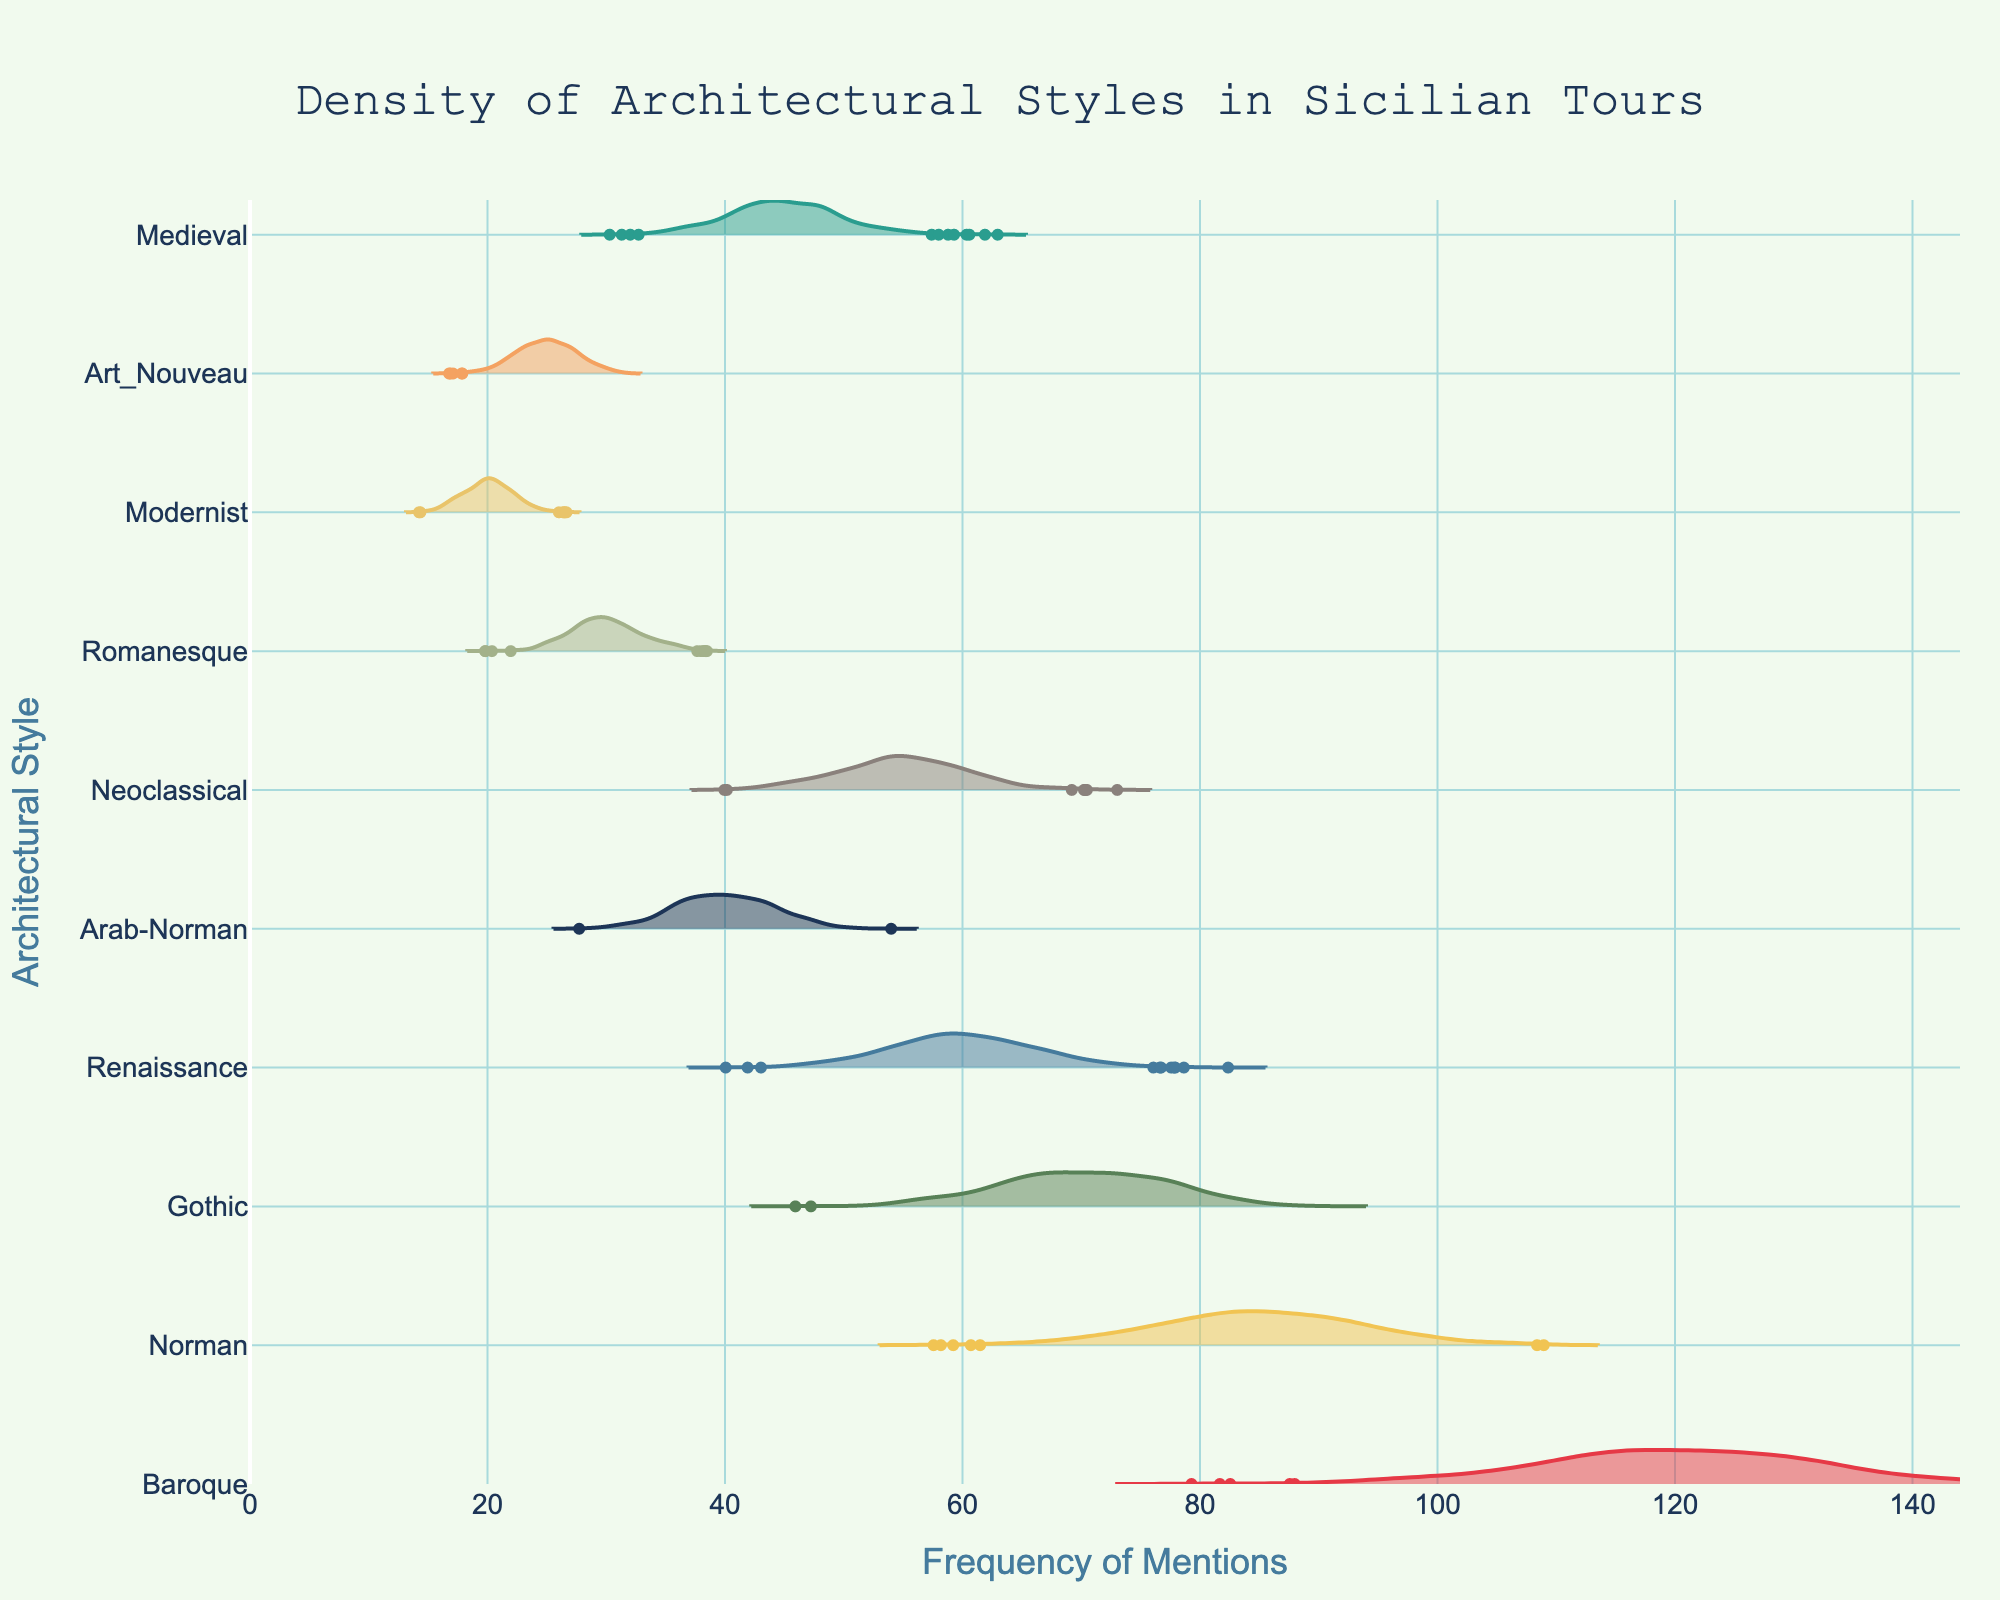What's the title of the plot? The title is displayed prominently at the top of the figure.
Answer: Density of Architectural Styles in Sicilian Tours What is the architectural style with the highest frequency of mentions? Look for the architectural style whose density plot is centered around the highest value on the x-axis.
Answer: Baroque Which style has the lowest frequency of mentions? Identify the architectural style whose density plot is centered around the lowest value on the x-axis.
Answer: Modernist How many architectural styles are displayed in the plot? Count the number of distinct density plots represented in the figure.
Answer: 10 Compare the frequency of mentions for Norman and Art Nouveau styles. Which one is mentioned more frequently? Locate the density plots for Norman and Art Nouveau and compare their center points along the x-axis.
Answer: Norman Which architectural style has a frequency of mentions closer to 45? Locate the density plot whose center point on the x-axis is closest to 45.
Answer: Medieval Find the styles whose densities are centered around between 50 and 60. Identify the density plots that peak between 50 and 60 on the x-axis.
Answer: Neoclassical, Renaissance What is the color used for the Gothic architectural style in the plot? Find the corresponding color of the Gothic density plot in the figure.
Answer: Blue (or #457B9D in code) Which architectural style has a wider spread in its density plot, Baroque or Medieval? Compare the horizontal width or spread of the density plots for Baroque and Medieval.
Answer: Baroque Determine the average frequency of mentions for Baroque, Renaissance, and Modernist styles. Sum the frequencies of mentions for Baroque (120), Renaissance (60), and Modernist (20), then divide by 3.
Answer: (120 + 60 + 20) / 3 = 66.67 